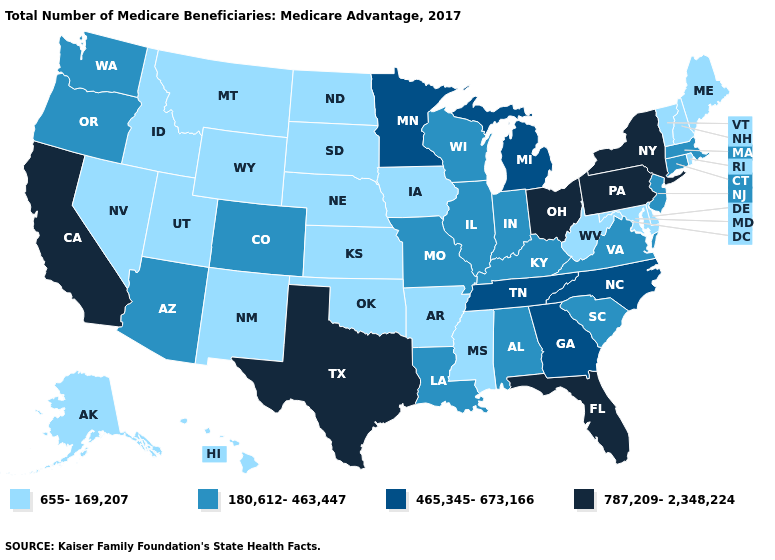What is the value of Alaska?
Short answer required. 655-169,207. Name the states that have a value in the range 180,612-463,447?
Concise answer only. Alabama, Arizona, Colorado, Connecticut, Illinois, Indiana, Kentucky, Louisiana, Massachusetts, Missouri, New Jersey, Oregon, South Carolina, Virginia, Washington, Wisconsin. What is the value of Illinois?
Quick response, please. 180,612-463,447. What is the value of Illinois?
Be succinct. 180,612-463,447. Does Oregon have the same value as Alaska?
Short answer required. No. What is the value of Maine?
Be succinct. 655-169,207. Does the map have missing data?
Keep it brief. No. Among the states that border Virginia , does Tennessee have the highest value?
Short answer required. Yes. Name the states that have a value in the range 465,345-673,166?
Give a very brief answer. Georgia, Michigan, Minnesota, North Carolina, Tennessee. Which states hav the highest value in the MidWest?
Keep it brief. Ohio. What is the highest value in the USA?
Short answer required. 787,209-2,348,224. Does Oregon have the same value as Idaho?
Answer briefly. No. Which states have the lowest value in the MidWest?
Keep it brief. Iowa, Kansas, Nebraska, North Dakota, South Dakota. How many symbols are there in the legend?
Short answer required. 4. Does Kansas have the lowest value in the USA?
Short answer required. Yes. 